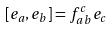Convert formula to latex. <formula><loc_0><loc_0><loc_500><loc_500>[ e _ { a } , e _ { b } ] = f _ { a b } ^ { c } e _ { c }</formula> 